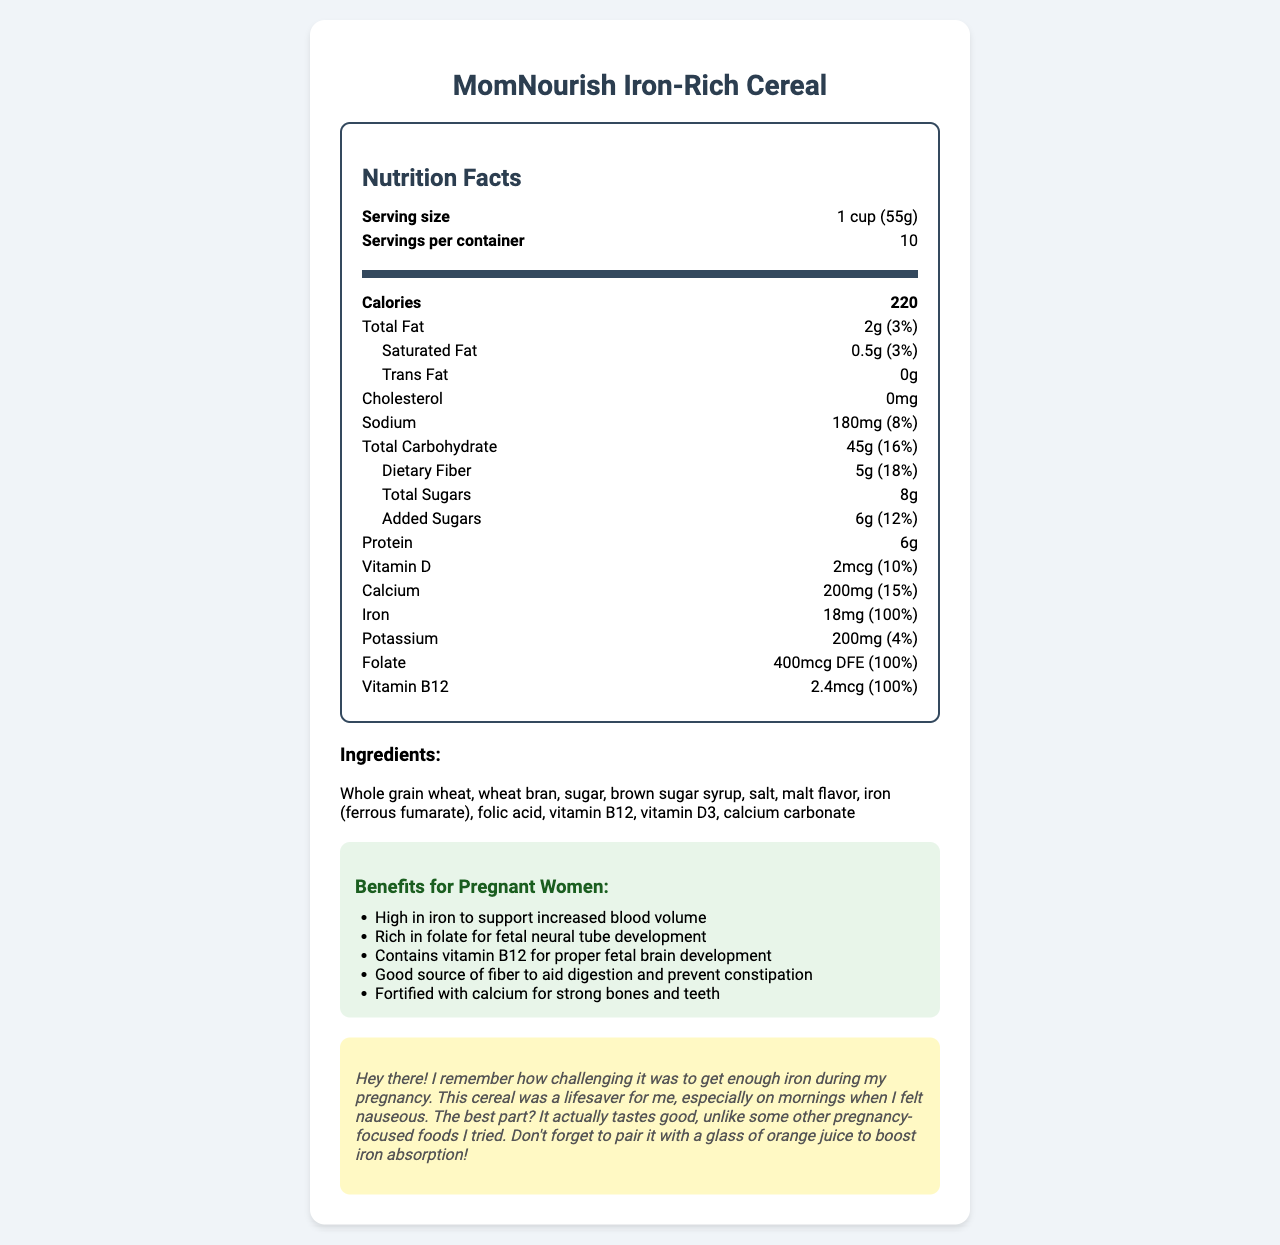What is the serving size for MomNourish Iron-Rich Cereal? The document lists the serving size as "1 cup (55g)" in the nutrition facts section.
Answer: 1 cup (55g) How many calories are in a serving of this cereal? The document specifies 220 calories per serving in the nutrition facts section.
Answer: 220 What percentage of the daily value of iron does one serving provide? The nutrition facts section states that each serving provides 100% of the daily value of iron.
Answer: 100% Which vitamin listed has the highest percentage of the daily value per serving? According to the document, vitamin B12 provides 100% of the daily value per serving, the same as iron and folate, but it is listed first among them.
Answer: vitamin B12 What is the main source of fiber in MomNourish Iron-Rich Cereal? The ingredient list mentions "Whole grain wheat" as the first ingredient, indicating it is the primary source.
Answer: Whole grain wheat What is the total amount of sugar in one serving? The nutrition facts list "Total Sugars" as 8g per serving.
Answer: 8g How much calcium is in one serving of this cereal? The document states that each serving contains 200mg of calcium, which is 15% of the daily value.
Answer: 200mg Does this cereal contain any cholesterol? The nutrition facts indicate 0mg of cholesterol per serving.
Answer: No What is the sodium content of one serving? The document lists 180mg of sodium per serving, which is 8% of the daily value.
Answer: 180mg Identify an ingredient used to fortify the cereal with iron. The ingredients list includes "iron (ferrous fumarate)".
Answer: ferrous fumarate Which of the following benefits is NOT listed for pregnant women: A. Supports increased blood volume B. Enhances skin health C. Aids in digestion D. Strong bones and teeth The document lists benefits such as supporting increased blood volume, aiding digestion, and strong bones and teeth, but does not mention enhancing skin health.
Answer: B Which of these vitamins has the same daily value percentage as iron in one serving? I. Vitamin D II. Vitamin B12 III. Folate Both vitamin B12 and folate have the same daily value percentage as iron, which is 100%.
Answer: II and III True or False: This cereal may contain traces of soy and tree nuts. The allergen information states that it may contain traces of soy and tree nuts.
Answer: True Summarize the main purpose and nutritional benefits of MomNourish Iron-Rich Cereal for pregnant women. The detailed document highlights the nutritional benefits and the specific ingredients included to provide these benefits, aiming to support the health needs of pregnant women.
Answer: MomNourish Iron-Rich Cereal is designed to provide essential nutrients for pregnant women, such as iron to support increased blood volume, folate for fetal neural tube development, vitamin B12 for proper fetal brain development, and fiber to aid digestion and prevent constipation. Additionally, it is fortified with calcium for strong bones and teeth. What is the source of potassium in this cereal? The document does not specify the source of potassium.
Answer: I don't know 